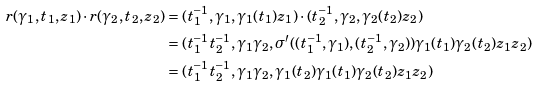Convert formula to latex. <formula><loc_0><loc_0><loc_500><loc_500>r ( \gamma _ { 1 } , t _ { 1 } , z _ { 1 } ) \cdot r ( \gamma _ { 2 } , t _ { 2 } , z _ { 2 } ) & = ( t _ { 1 } ^ { - 1 } , \gamma _ { 1 } , \gamma _ { 1 } ( t _ { 1 } ) z _ { 1 } ) \cdot ( t _ { 2 } ^ { - 1 } , \gamma _ { 2 } , \gamma _ { 2 } ( t _ { 2 } ) z _ { 2 } ) \\ & = ( t _ { 1 } ^ { - 1 } t _ { 2 } ^ { - 1 } , \gamma _ { 1 } \gamma _ { 2 } , \sigma ^ { \prime } ( ( t _ { 1 } ^ { - 1 } , \gamma _ { 1 } ) , ( t _ { 2 } ^ { - 1 } , \gamma _ { 2 } ) ) \gamma _ { 1 } ( t _ { 1 } ) \gamma _ { 2 } ( t _ { 2 } ) z _ { 1 } z _ { 2 } ) \\ & = ( t _ { 1 } ^ { - 1 } t _ { 2 } ^ { - 1 } , \gamma _ { 1 } \gamma _ { 2 } , \gamma _ { 1 } ( t _ { 2 } ) \gamma _ { 1 } ( t _ { 1 } ) \gamma _ { 2 } ( t _ { 2 } ) z _ { 1 } z _ { 2 } )</formula> 